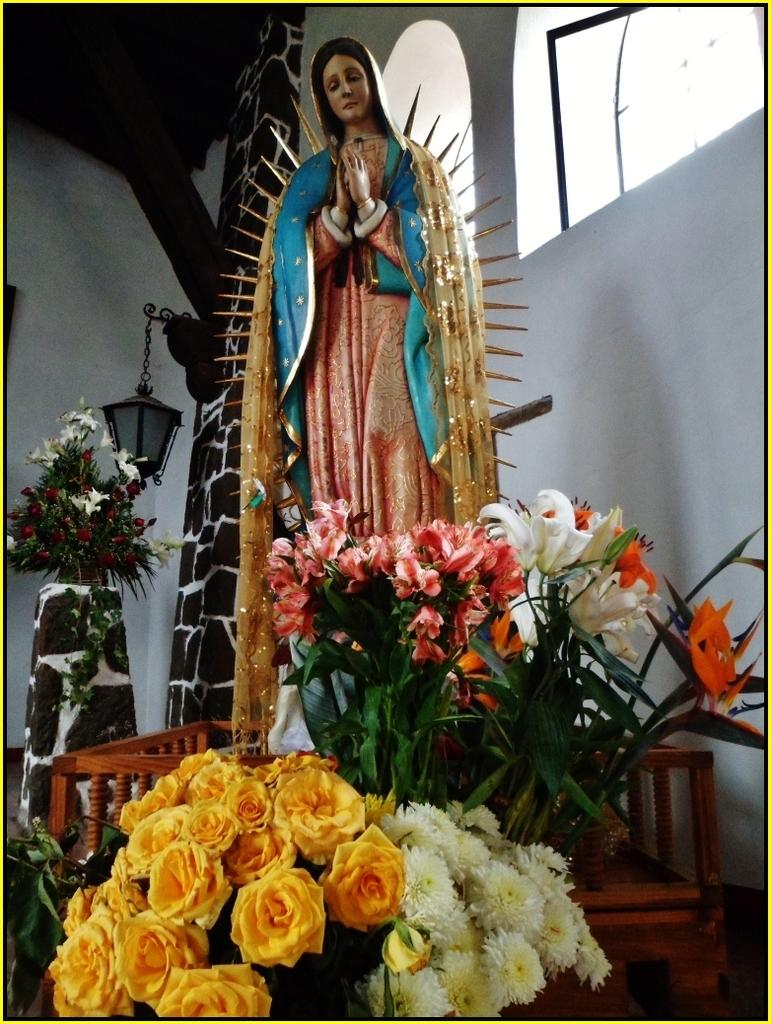What type of plants can be seen in the image? There are flowers in the image. What colors are the flowers? The colors of the flowers are yellow, orange, and white. What other object is present in the image? There is a light in the image. What type of artwork is visible in the image? There is a sculpture of a woman in the image. How many pages are visible in the image? There are no pages present in the image. What type of ducks can be seen swimming in the image? There are no ducks present in the image. 